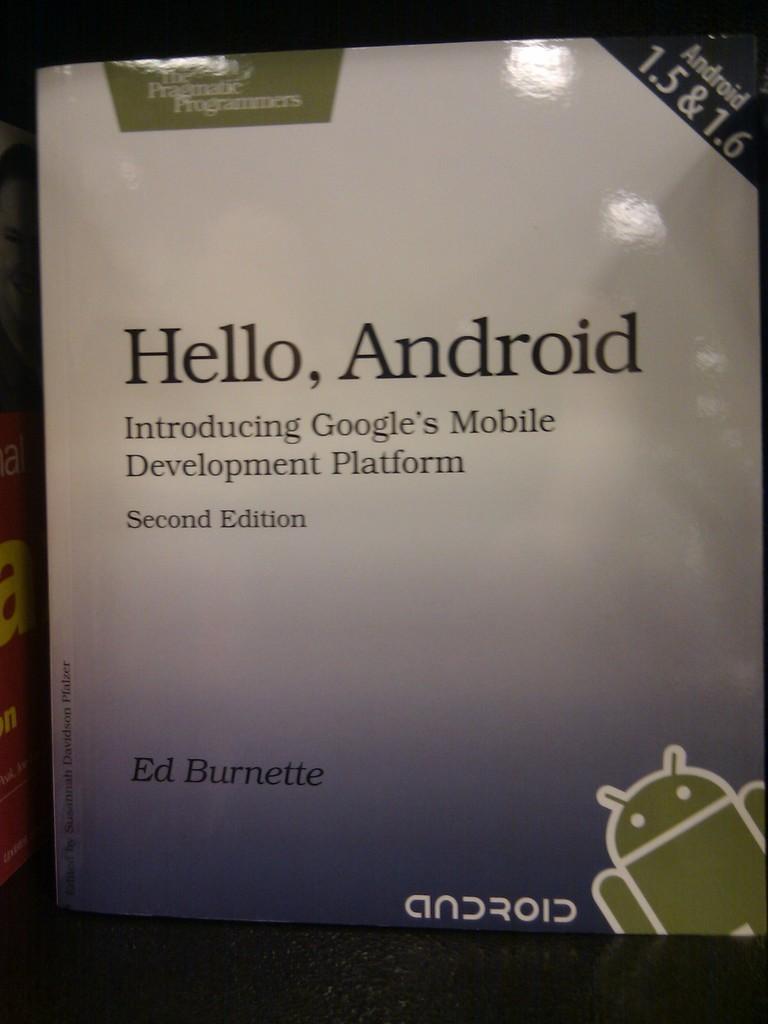What edition is this report for android phones?
Offer a terse response. Second. Who wrote this book?
Ensure brevity in your answer.  Ed burnette. 